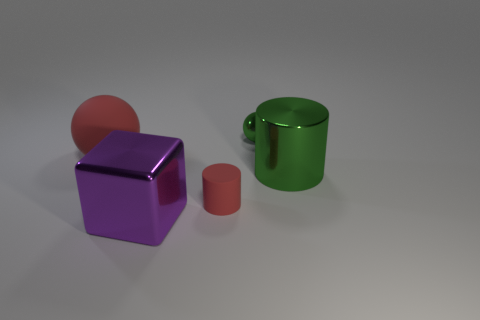What is the size of the sphere that is made of the same material as the big purple block?
Provide a short and direct response. Small. What is the shape of the purple shiny thing?
Your answer should be very brief. Cube. Is the material of the green ball the same as the red thing that is to the left of the tiny red matte cylinder?
Offer a terse response. No. How many objects are big cyan cubes or red spheres?
Provide a short and direct response. 1. Are there any small cyan rubber blocks?
Your answer should be very brief. No. The shiny object in front of the object on the right side of the small sphere is what shape?
Offer a terse response. Cube. What number of objects are either objects left of the large purple thing or balls that are in front of the tiny green thing?
Make the answer very short. 1. There is a red sphere that is the same size as the purple thing; what is it made of?
Your answer should be very brief. Rubber. The metallic cylinder has what color?
Offer a very short reply. Green. What is the material of the large object that is both left of the small green metallic object and behind the tiny red rubber cylinder?
Your answer should be very brief. Rubber. 